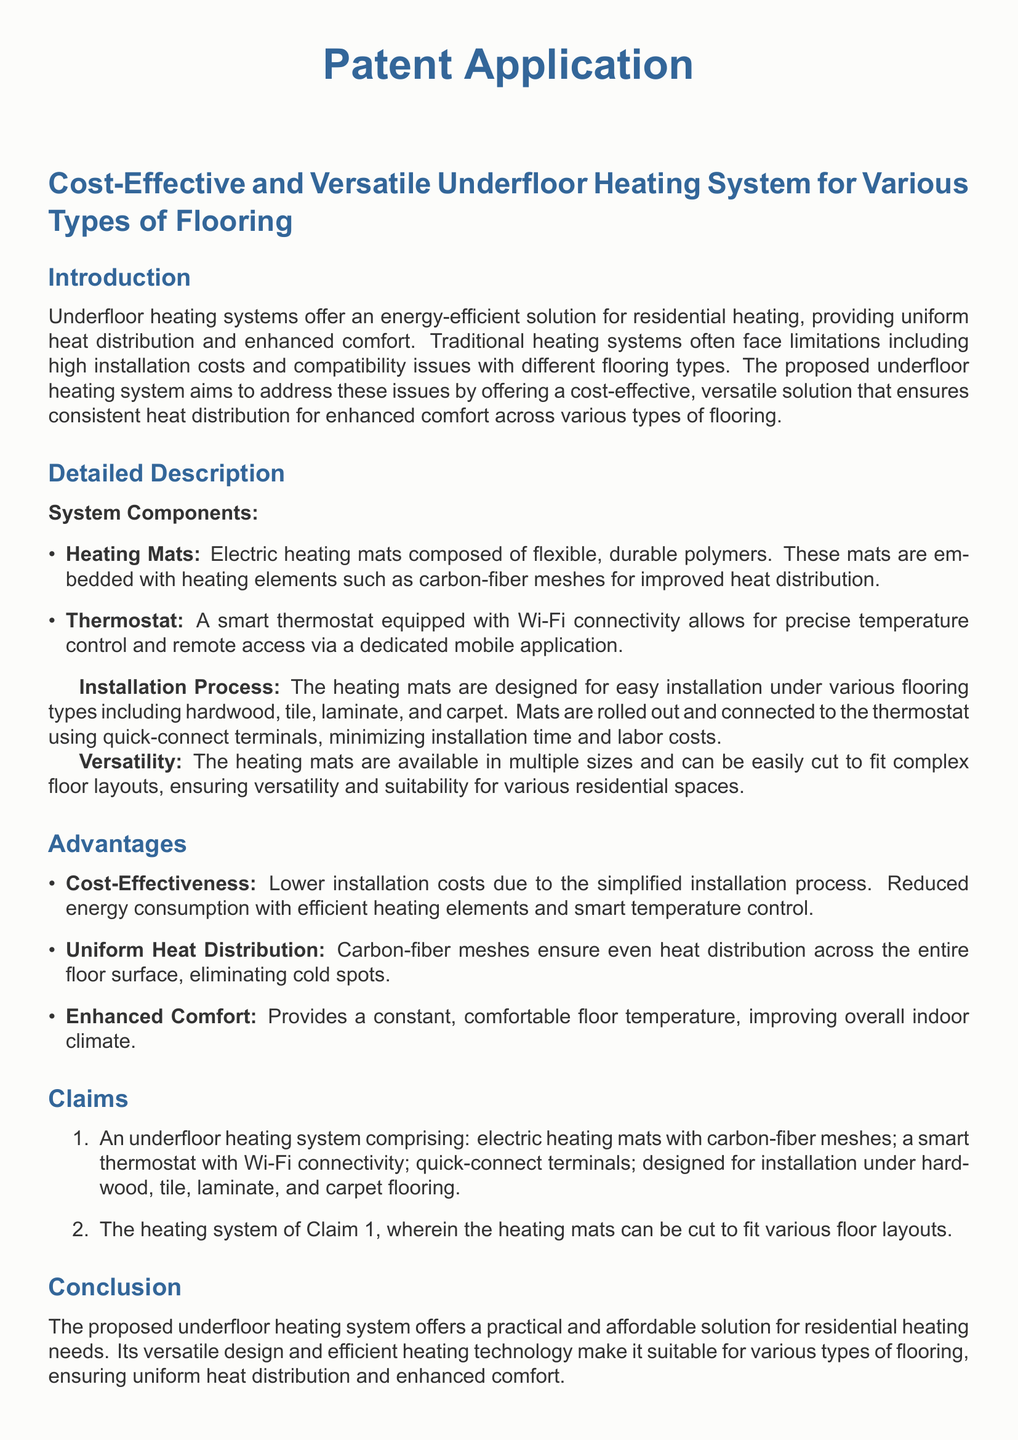What is the main purpose of the underfloor heating system? The purpose of the system is to provide an energy-efficient solution for residential heating, ensuring uniform heat distribution and enhanced comfort.
Answer: energy-efficient solution What materials are the heating mats made of? The heating mats are composed of flexible, durable polymers and embedded with heating elements such as carbon-fiber meshes.
Answer: flexible, durable polymers How does the thermostat connect to the heating mats? The thermostat connects to the heating mats using quick-connect terminals, which minimizes installation time and labor costs.
Answer: quick-connect terminals What types of flooring can the heating system be installed under? The heating system is designed for installation under hardwood, tile, laminate, and carpet flooring.
Answer: hardwood, tile, laminate, carpet What is one advantage of the proposed heating system? One advantage mentioned is that the system has lower installation costs due to the simplified installation process.
Answer: lower installation costs How can users control the thermostat? Users can control the thermostat via a dedicated mobile application, allowing for precise temperature control and remote access.
Answer: dedicated mobile application What aspect of comfort does the heating system enhance? The heating system enhances comfort by providing a constant, comfortable floor temperature, improving overall indoor climate.
Answer: constant, comfortable floor temperature What makes the heating mats versatile? The mats are versatile because they are available in multiple sizes and can be easily cut to fit complex floor layouts.
Answer: can be easily cut What feature allows efficient energy consumption in the heating system? The efficient energy consumption is facilitated by the smart temperature control of the thermostat.
Answer: smart temperature control What claim specifies the heating mats can be cut? Claim 2 specifies that the heating mats can be cut to fit various floor layouts.
Answer: Claim 2 